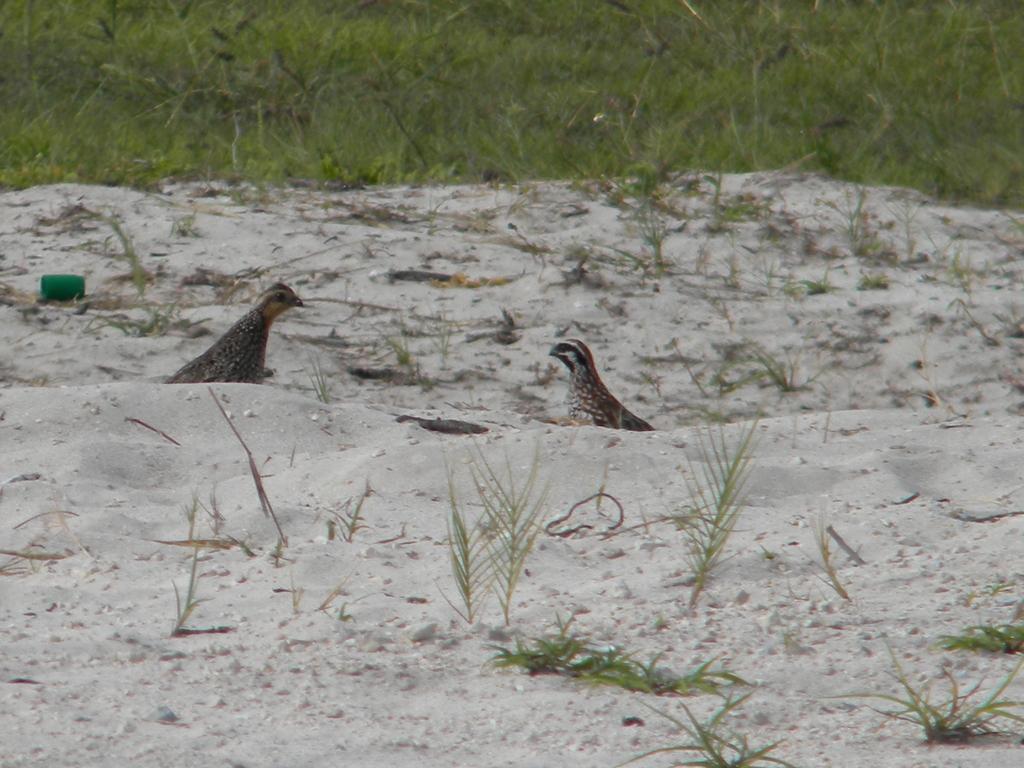How would you summarize this image in a sentence or two? In this image, we can see two birds, ground, plants, grass. Top of the image, we can see a green color view. 